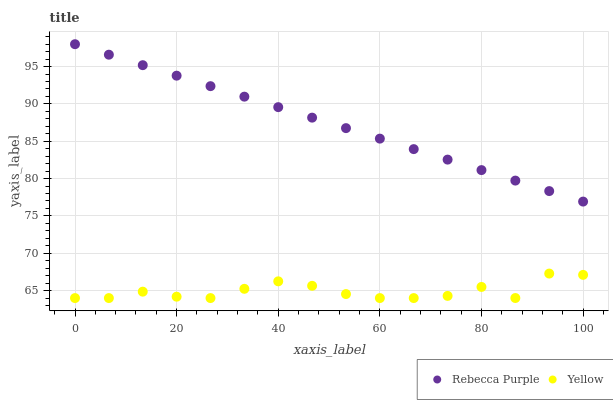Does Yellow have the minimum area under the curve?
Answer yes or no. Yes. Does Rebecca Purple have the maximum area under the curve?
Answer yes or no. Yes. Does Yellow have the maximum area under the curve?
Answer yes or no. No. Is Rebecca Purple the smoothest?
Answer yes or no. Yes. Is Yellow the roughest?
Answer yes or no. Yes. Is Yellow the smoothest?
Answer yes or no. No. Does Yellow have the lowest value?
Answer yes or no. Yes. Does Rebecca Purple have the highest value?
Answer yes or no. Yes. Does Yellow have the highest value?
Answer yes or no. No. Is Yellow less than Rebecca Purple?
Answer yes or no. Yes. Is Rebecca Purple greater than Yellow?
Answer yes or no. Yes. Does Yellow intersect Rebecca Purple?
Answer yes or no. No. 